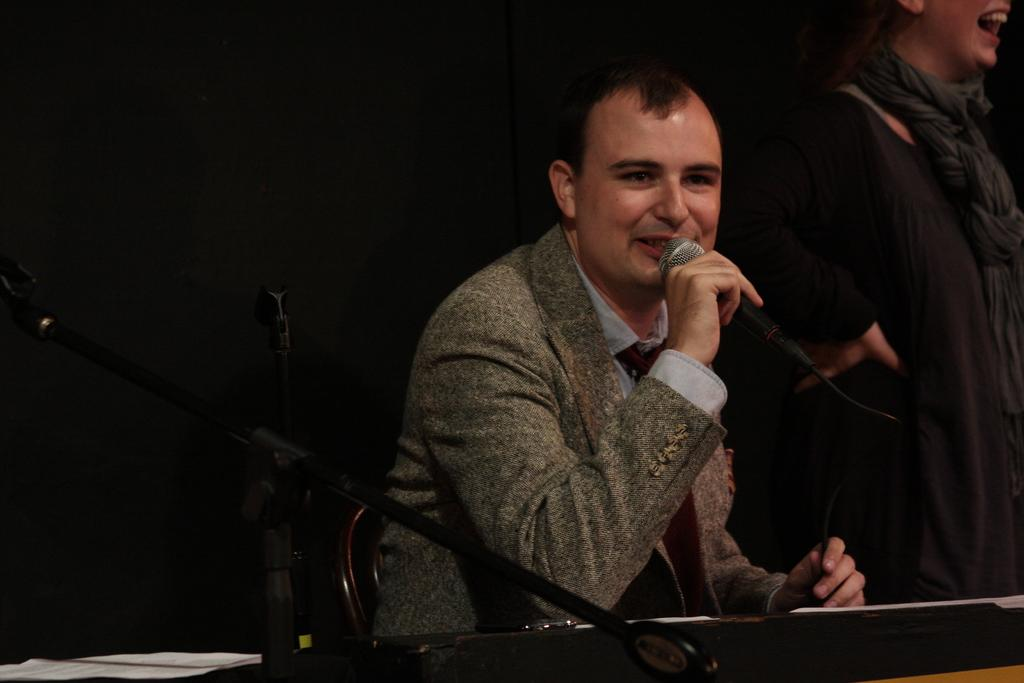How many people are present in the image? There are two people in the image. Can you describe one of the individuals in the image? One of the people is a man. What is the man doing in the image? The man is sitting. What is the man holding in the image? The man is holding a mic. What angle is the man coughing at in the image? The man is not coughing in the image; he is holding a mic. 